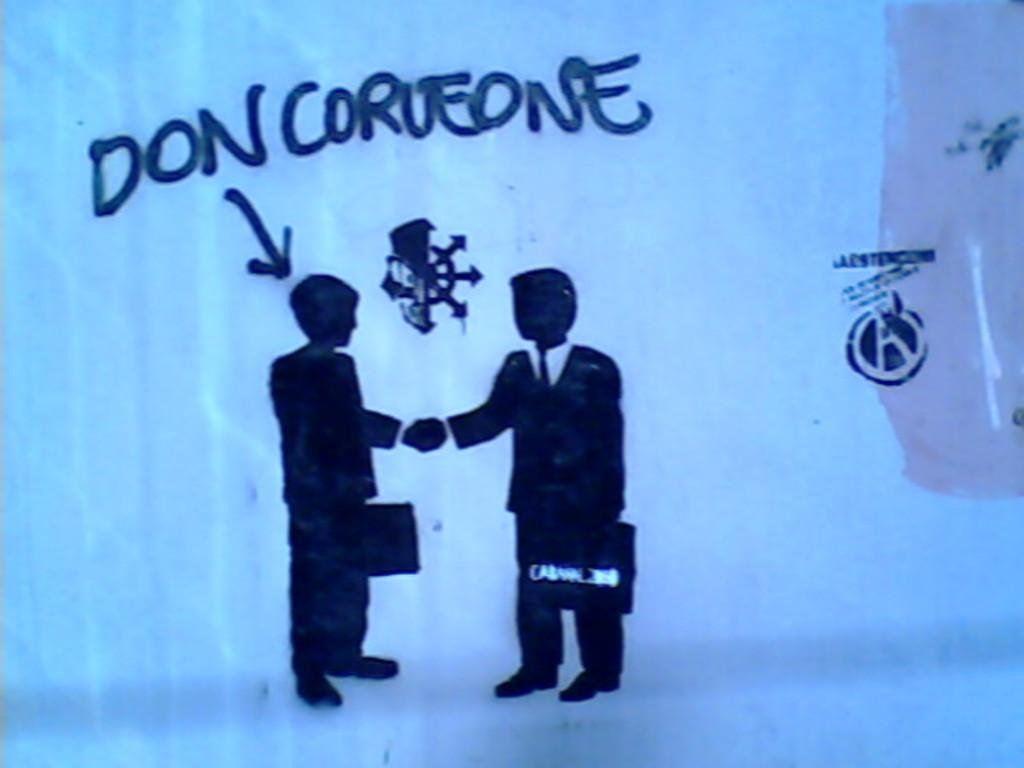<image>
Describe the image concisely. A silhouette of two men shaking hands, one of which is named Don Corueone. 